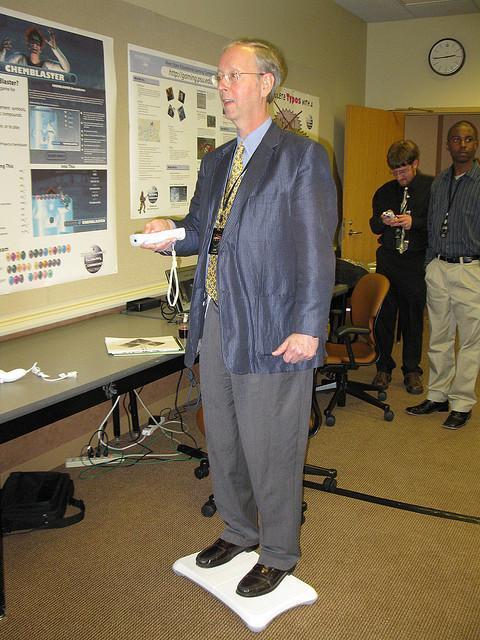How many people are there?
Give a very brief answer. 3. 